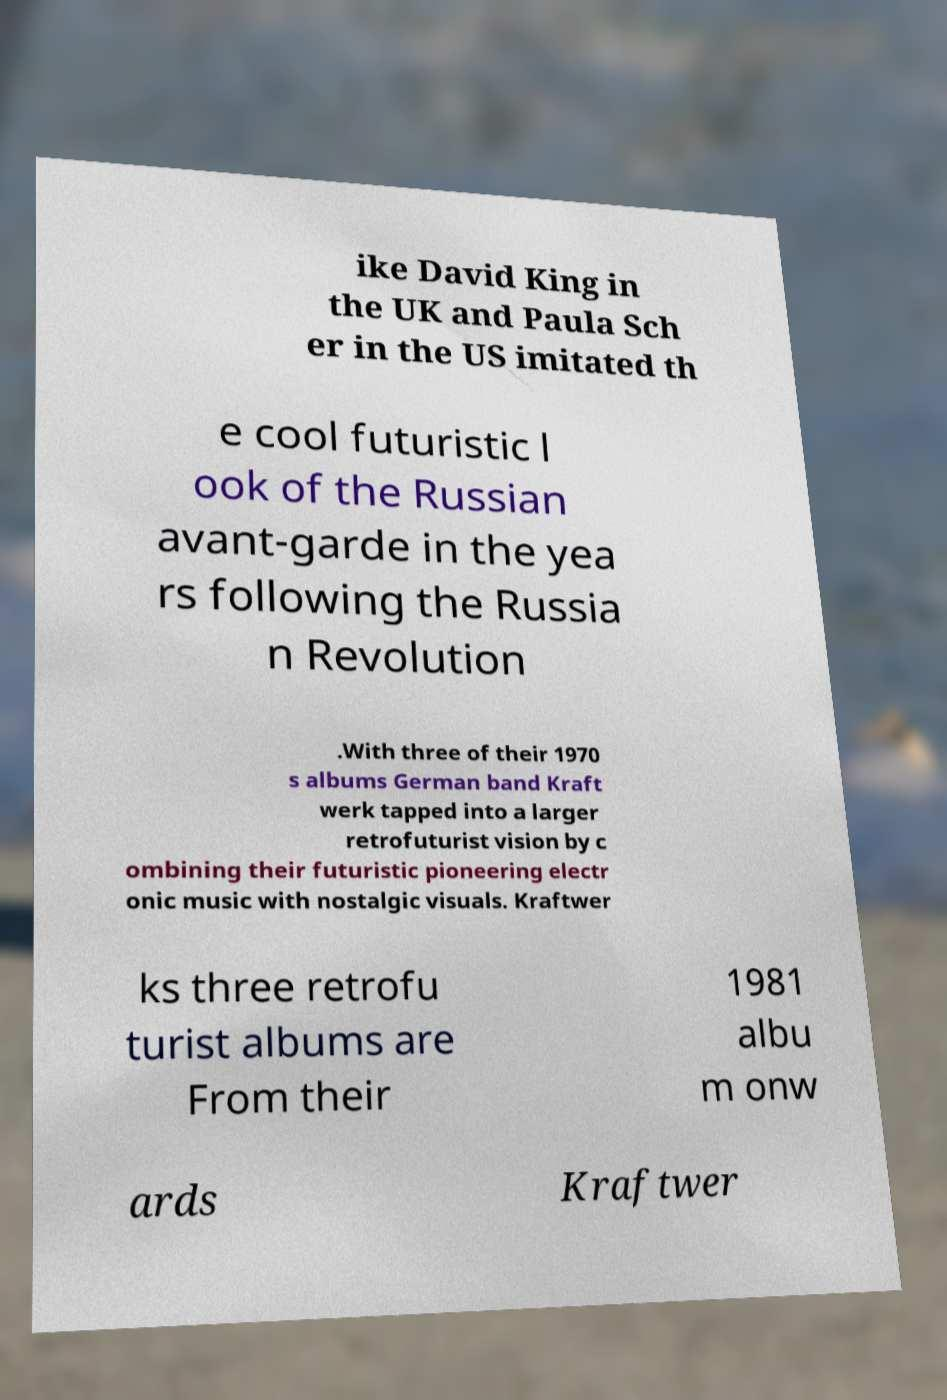Could you extract and type out the text from this image? ike David King in the UK and Paula Sch er in the US imitated th e cool futuristic l ook of the Russian avant-garde in the yea rs following the Russia n Revolution .With three of their 1970 s albums German band Kraft werk tapped into a larger retrofuturist vision by c ombining their futuristic pioneering electr onic music with nostalgic visuals. Kraftwer ks three retrofu turist albums are From their 1981 albu m onw ards Kraftwer 